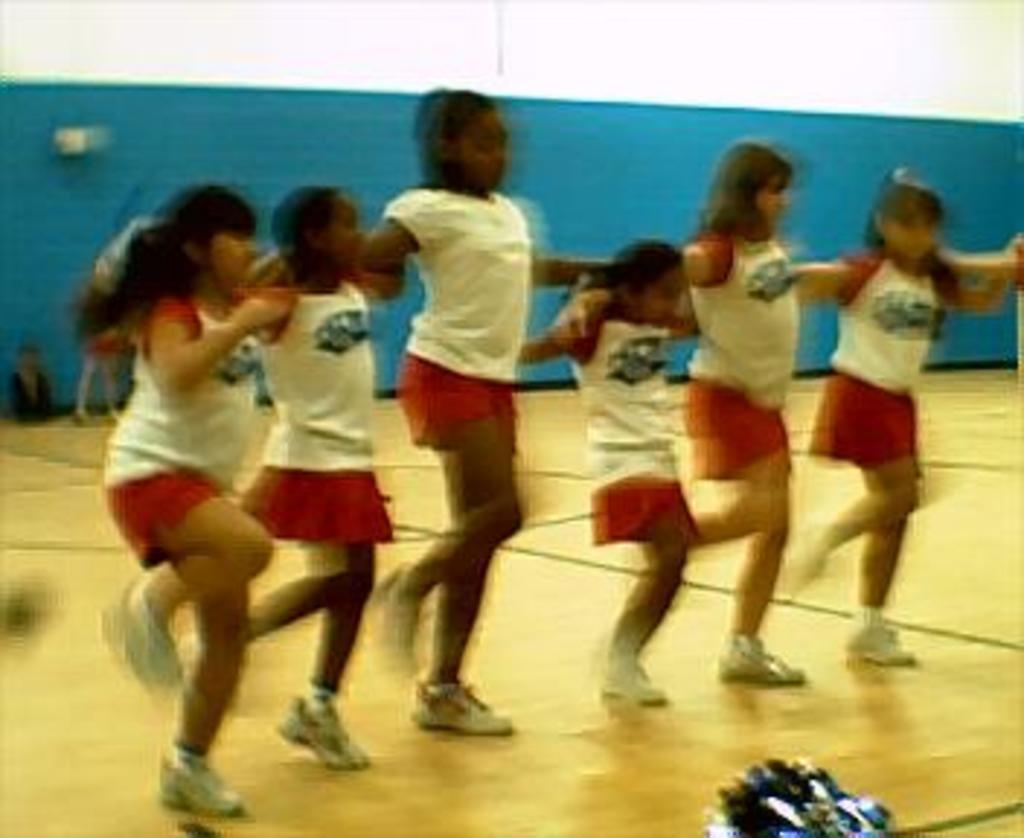How many people are in the image? There are six girls in the image. What type of flooring is visible in the image? There is a wooden floor in the image. What can be seen towards the bottom of the image? There is an object towards the bottom of the image. What is visible in the background of the image? There is a wall in the background of the image. What grade is the girl in the middle of the image? There is no indication of the girls' grades in the image. How does the brain of the girl on the left side of the image function? There is no information about the girls' brains or their functions in the image. 